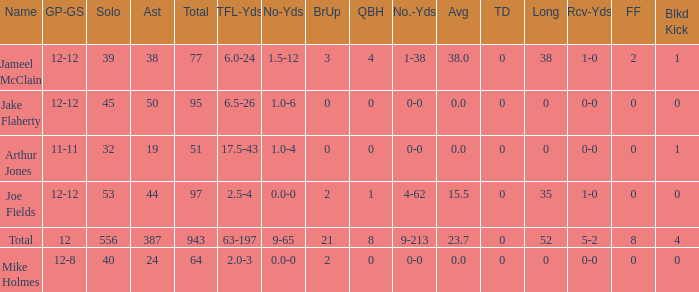What is the largest number of tds scored for a player? 0.0. 